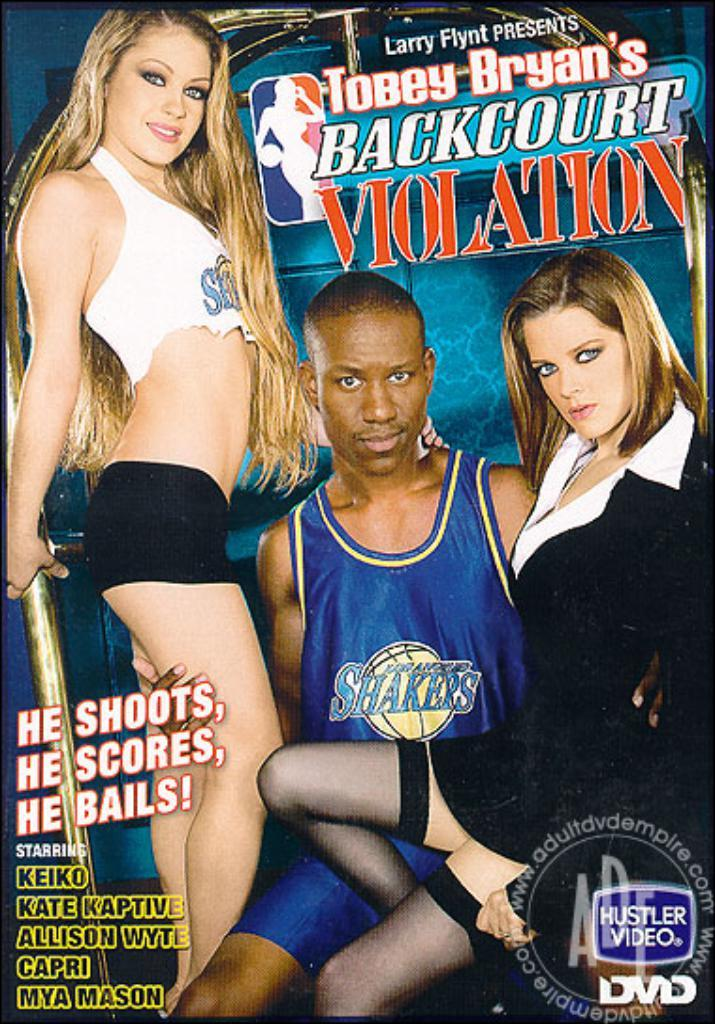<image>
Summarize the visual content of the image. The cover of a porn DVD called Tobey Bryan's Backcourt Violation. 